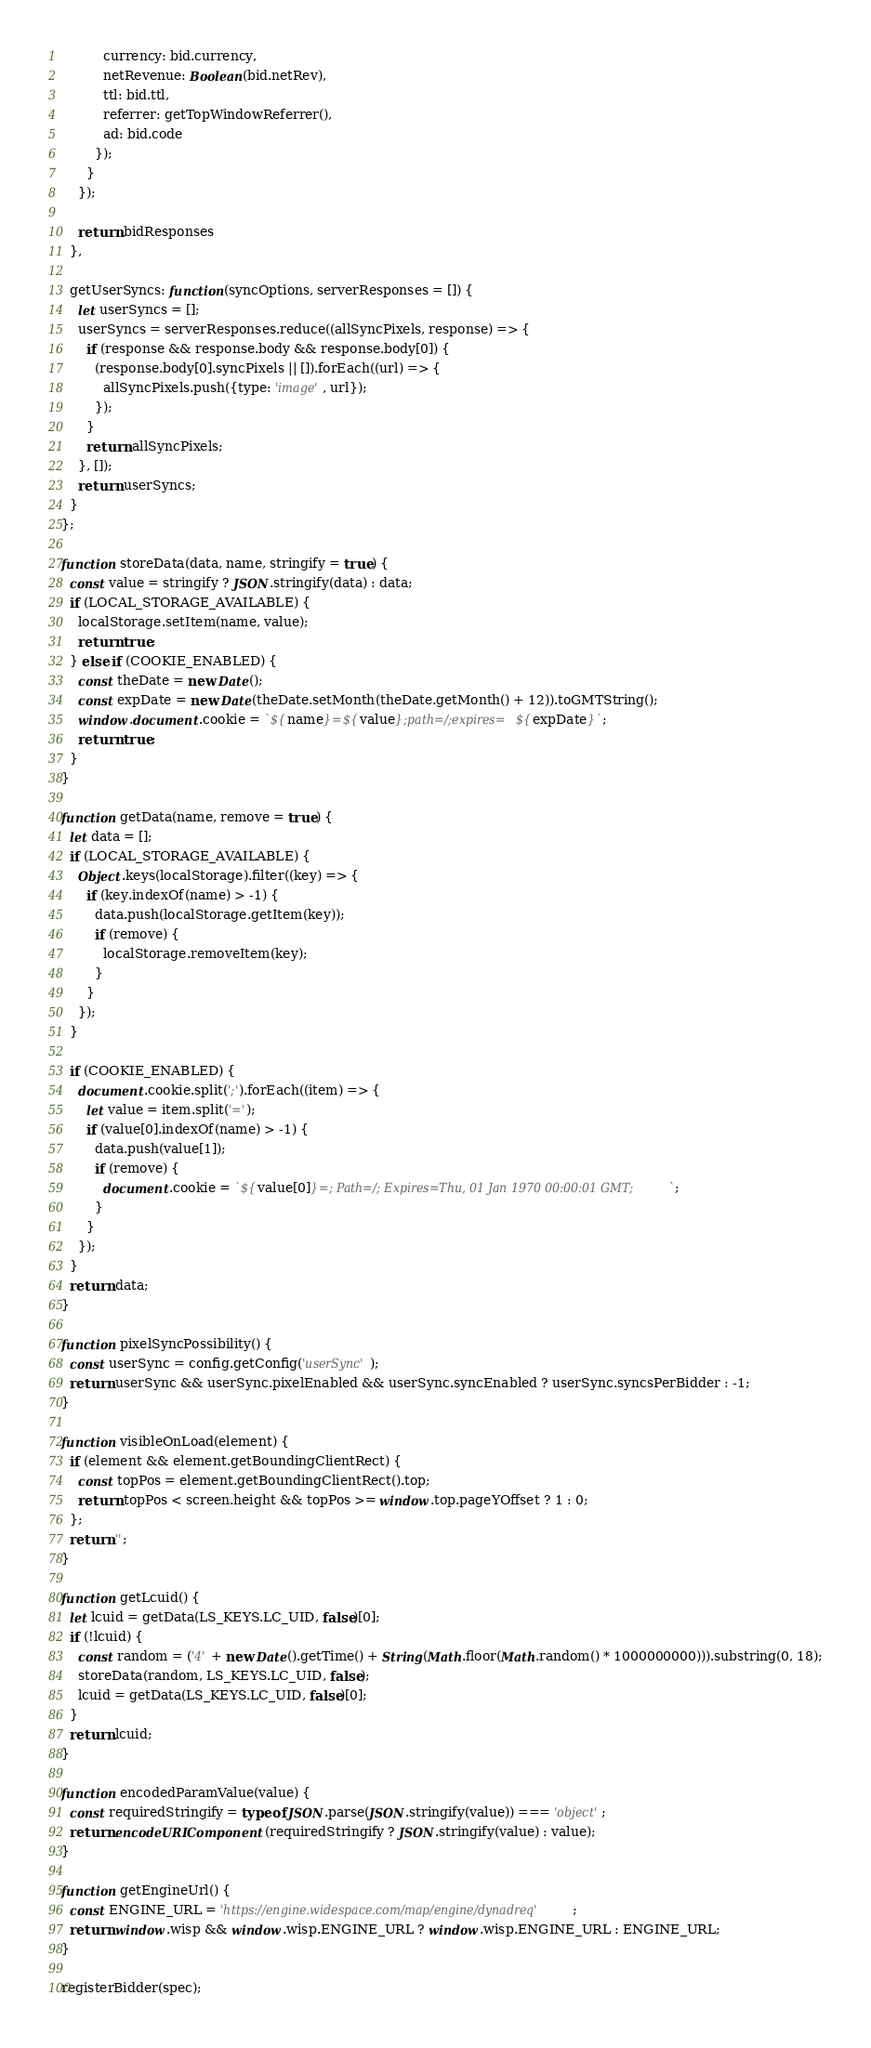<code> <loc_0><loc_0><loc_500><loc_500><_JavaScript_>          currency: bid.currency,
          netRevenue: Boolean(bid.netRev),
          ttl: bid.ttl,
          referrer: getTopWindowReferrer(),
          ad: bid.code
        });
      }
    });

    return bidResponses
  },

  getUserSyncs: function(syncOptions, serverResponses = []) {
    let userSyncs = [];
    userSyncs = serverResponses.reduce((allSyncPixels, response) => {
      if (response && response.body && response.body[0]) {
        (response.body[0].syncPixels || []).forEach((url) => {
          allSyncPixels.push({type: 'image', url});
        });
      }
      return allSyncPixels;
    }, []);
    return userSyncs;
  }
};

function storeData(data, name, stringify = true) {
  const value = stringify ? JSON.stringify(data) : data;
  if (LOCAL_STORAGE_AVAILABLE) {
    localStorage.setItem(name, value);
    return true;
  } else if (COOKIE_ENABLED) {
    const theDate = new Date();
    const expDate = new Date(theDate.setMonth(theDate.getMonth() + 12)).toGMTString();
    window.document.cookie = `${name}=${value};path=/;expires=${expDate}`;
    return true;
  }
}

function getData(name, remove = true) {
  let data = [];
  if (LOCAL_STORAGE_AVAILABLE) {
    Object.keys(localStorage).filter((key) => {
      if (key.indexOf(name) > -1) {
        data.push(localStorage.getItem(key));
        if (remove) {
          localStorage.removeItem(key);
        }
      }
    });
  }

  if (COOKIE_ENABLED) {
    document.cookie.split(';').forEach((item) => {
      let value = item.split('=');
      if (value[0].indexOf(name) > -1) {
        data.push(value[1]);
        if (remove) {
          document.cookie = `${value[0]}=; Path=/; Expires=Thu, 01 Jan 1970 00:00:01 GMT;`;
        }
      }
    });
  }
  return data;
}

function pixelSyncPossibility() {
  const userSync = config.getConfig('userSync');
  return userSync && userSync.pixelEnabled && userSync.syncEnabled ? userSync.syncsPerBidder : -1;
}

function visibleOnLoad(element) {
  if (element && element.getBoundingClientRect) {
    const topPos = element.getBoundingClientRect().top;
    return topPos < screen.height && topPos >= window.top.pageYOffset ? 1 : 0;
  };
  return '';
}

function getLcuid() {
  let lcuid = getData(LS_KEYS.LC_UID, false)[0];
  if (!lcuid) {
    const random = ('4' + new Date().getTime() + String(Math.floor(Math.random() * 1000000000))).substring(0, 18);
    storeData(random, LS_KEYS.LC_UID, false);
    lcuid = getData(LS_KEYS.LC_UID, false)[0];
  }
  return lcuid;
}

function encodedParamValue(value) {
  const requiredStringify = typeof JSON.parse(JSON.stringify(value)) === 'object';
  return encodeURIComponent(requiredStringify ? JSON.stringify(value) : value);
}

function getEngineUrl() {
  const ENGINE_URL = 'https://engine.widespace.com/map/engine/dynadreq';
  return window.wisp && window.wisp.ENGINE_URL ? window.wisp.ENGINE_URL : ENGINE_URL;
}

registerBidder(spec);
</code> 